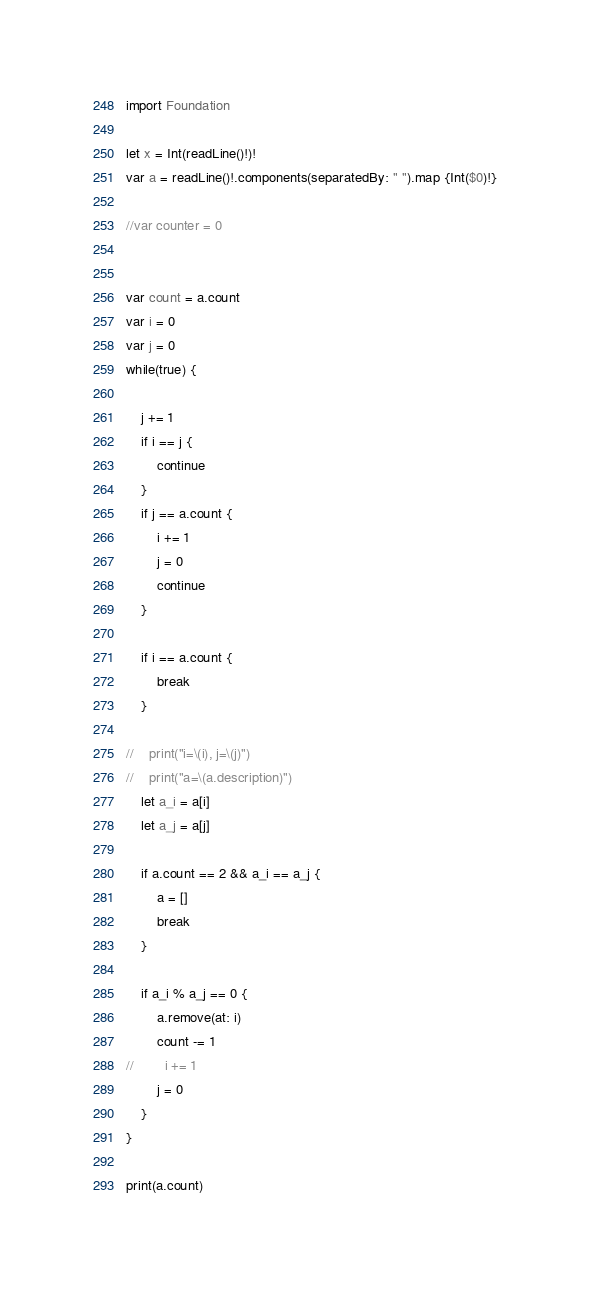<code> <loc_0><loc_0><loc_500><loc_500><_Swift_>import Foundation

let x = Int(readLine()!)!
var a = readLine()!.components(separatedBy: " ").map {Int($0)!}

//var counter = 0


var count = a.count
var i = 0
var j = 0
while(true) {
    
    j += 1
    if i == j {
        continue
    }
    if j == a.count {
        i += 1
        j = 0
        continue
    }
    
    if i == a.count {
        break
    }
    
//    print("i=\(i), j=\(j)")
//    print("a=\(a.description)")
    let a_i = a[i]
    let a_j = a[j]
    
    if a.count == 2 && a_i == a_j {
        a = []
        break
    }
    
    if a_i % a_j == 0 {
        a.remove(at: i)
        count -= 1
//        i += 1
        j = 0
    }
}

print(a.count)
</code> 